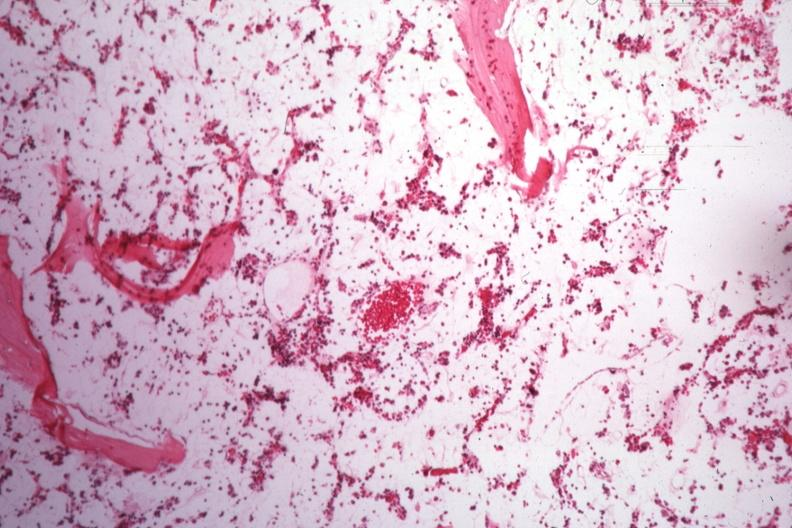what is present?
Answer the question using a single word or phrase. Hematologic 